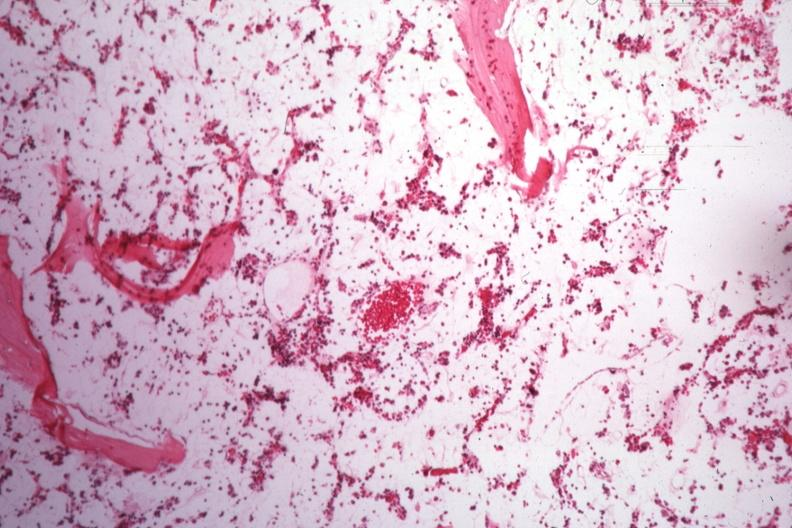what is present?
Answer the question using a single word or phrase. Hematologic 